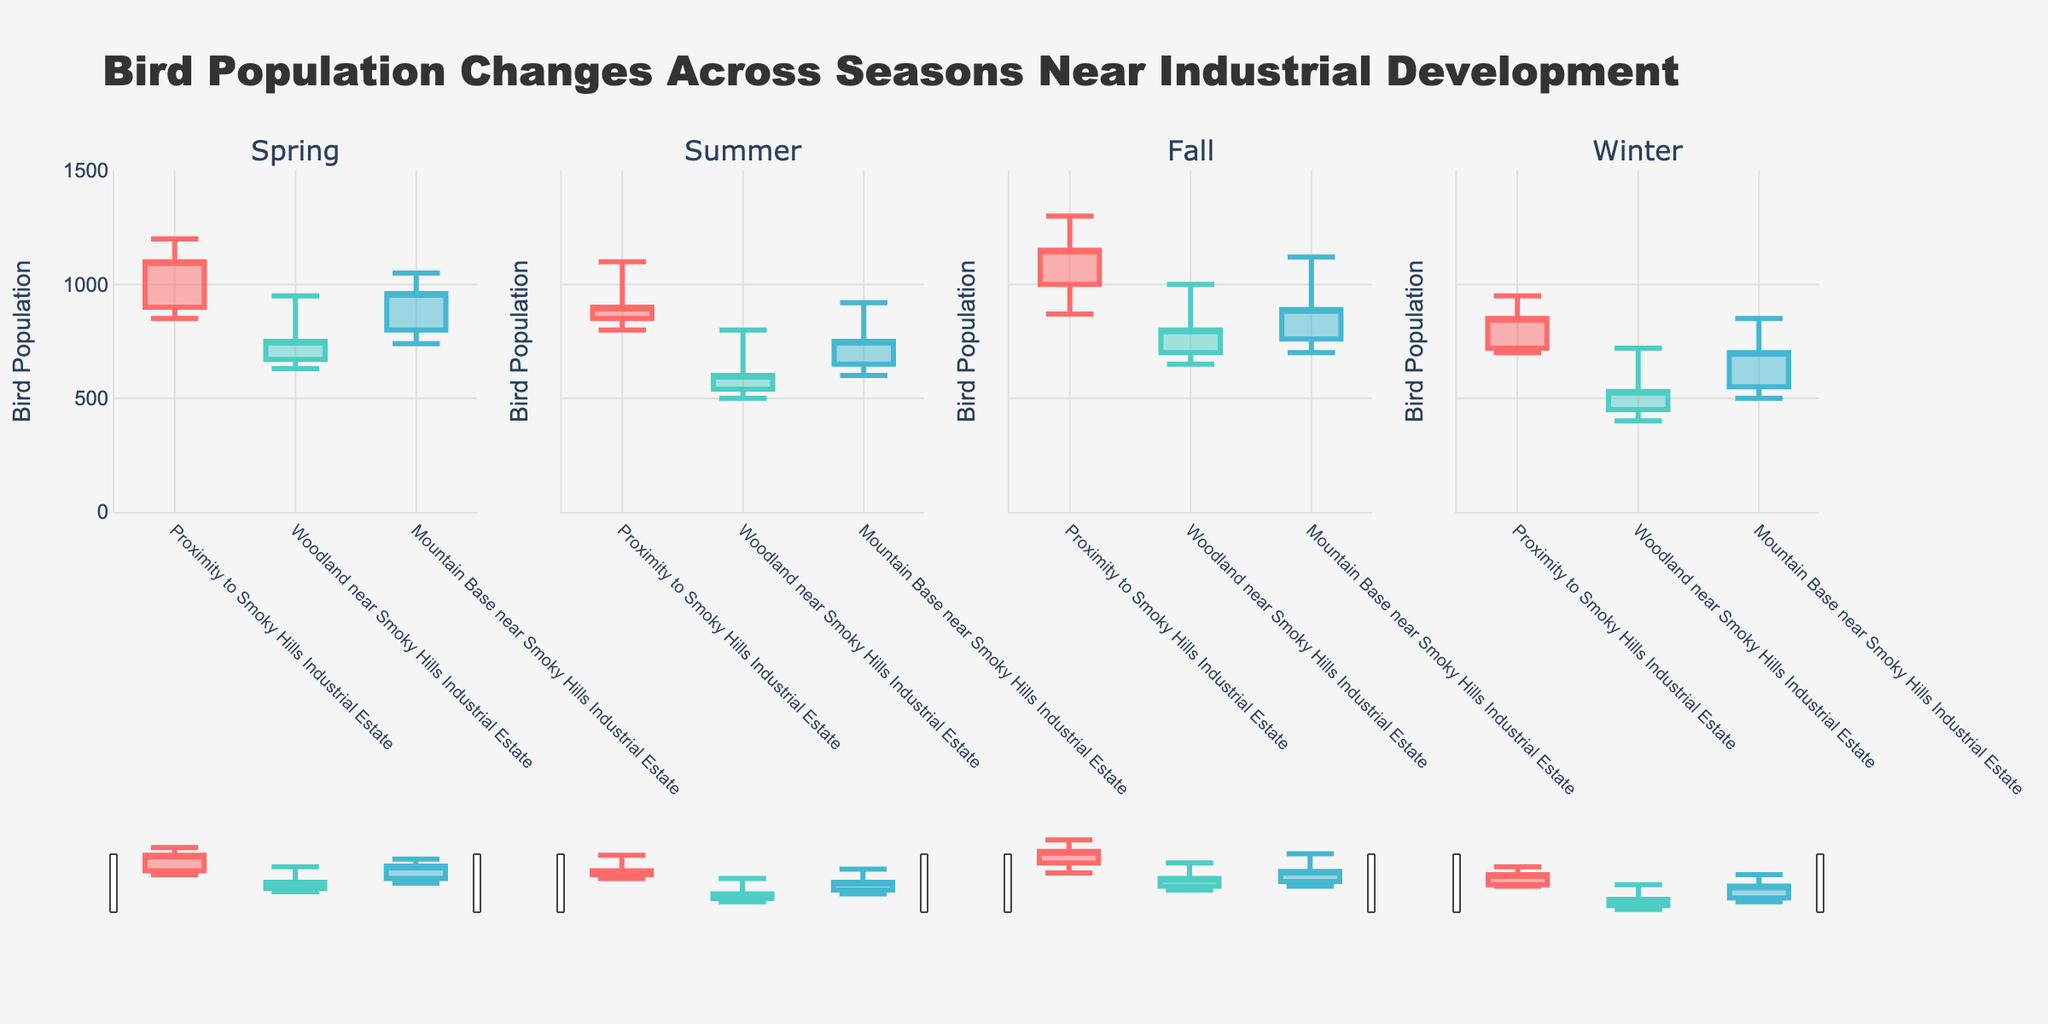What is the title of the figure? The title of the figure is usually located at the top center. It states the main topic or the purpose of the visualization.
Answer: Bird Population Changes Across Seasons Near Industrial Development How many subplots are present in the figure, and what do they represent? By observing the layout of the figure, we can count and identify the distinct sections. Each subplot represents bird population changes for each season.
Answer: 4 subplots representing Spring, Summer, Fall, and Winter Which location has the highest bird population in Spring? By examining the candlestick in the Spring subplot, we look for the highest point among the three locations. The candlestick representing "Proximity to Smoky Hills Industrial Estate" has the highest max population of 1200.
Answer: Proximity to Smoky Hills Industrial Estate During which season do the "Woodland near Smoky Hills Industrial Estate" experience the lowest minimum bird population? By analyzing the minimum population values (the bottom of the wicks) in all the subplots, we identify the lowest point for this location, which occurs in Winter with a value of 400.
Answer: Winter What is the range in bird population fluctuation for "Mountain Base near Smoky Hills Industrial Estate" during Summer? To calculate the range, subtract the minimum population value from the maximum population value for this location during Summer. The values are 920 (max) and 600 (min), thus 920 - 600 = 320.
Answer: 320 Which season shows the largest increase in bird population for the "Proximity to Smoky Hills Industrial Estate"? To find the largest increase, we compare the opening and closing populations for each season. Fall shows an increase from 1000 to 1150, which is the largest increase of 150.
Answer: Fall Contrast the closing bird population for "Woodland near Smoky Hills Industrial Estate" between Spring and Winter. Which season has a higher closing population, and by how much? Compare the closing populations for both seasons (750 in Spring and 530 in Winter). Subtract the lower one from the higher one (750 - 530 = 220).
Answer: Spring has a higher closing population by 220 What was the bird population trend like for "Proximity to Smoky Hills Industrial Estate" in Summer? Increasing or decreasing? Analyze the opening and closing populations. In Summer, the opening population is 850 and the closing is 900, indicating an increasing trend.
Answer: Increasing For the "Mountain Base near Smoky Hills Industrial Estate," what was the highest population reached in Fall? Identify the highest point (top of the wick) in the candlestick for this location in the Fall subplot, which is 1120.
Answer: 1120 